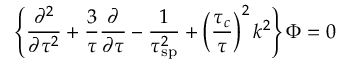Convert formula to latex. <formula><loc_0><loc_0><loc_500><loc_500>\left \{ { \frac { \partial ^ { 2 } } { \partial \tau ^ { 2 } } } + { \frac { 3 } { \tau } } { \frac { \partial } { \partial \tau } } - { \frac { 1 } { \tau _ { s p } ^ { 2 } } } + \left ( { \frac { \tau _ { c } } { \tau } } \right ) ^ { 2 } k ^ { 2 } \right \} { \Phi } = 0</formula> 